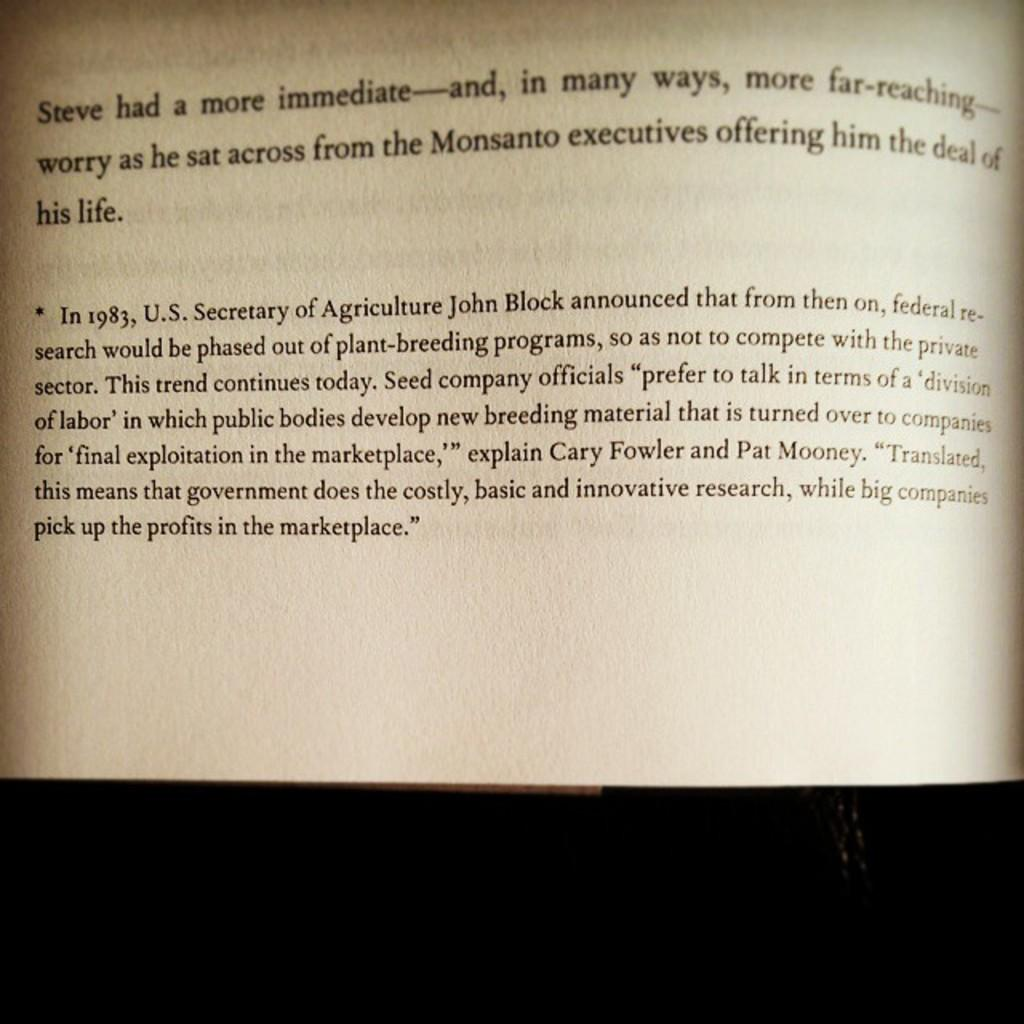<image>
Summarize the visual content of the image. A book is open to page discussing a man named Steve 